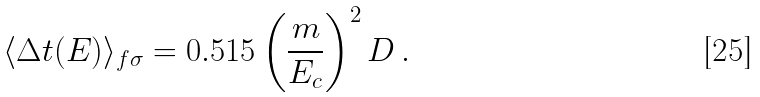<formula> <loc_0><loc_0><loc_500><loc_500>\langle \Delta t ( E ) \rangle _ { f \sigma } = 0 . 5 1 5 \left ( \frac { m } { E _ { c } } \right ) ^ { 2 } D \, .</formula> 